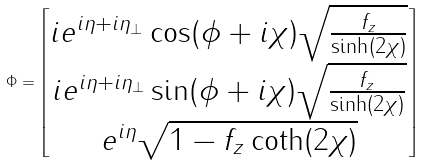<formula> <loc_0><loc_0><loc_500><loc_500>\Phi = \begin{bmatrix} i e ^ { i \eta + i \eta _ { \perp } } \cos ( \phi + i \chi ) \sqrt { \frac { f _ { z } } { \sinh ( 2 \chi ) } } \\ i e ^ { i \eta + i \eta _ { \perp } } \sin ( \phi + i \chi ) \sqrt { \frac { f _ { z } } { \sinh ( 2 \chi ) } } \\ e ^ { i \eta } \sqrt { 1 - f _ { z } \coth ( 2 \chi ) } \end{bmatrix}</formula> 